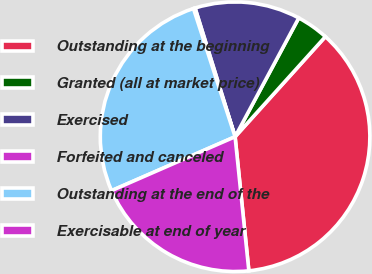<chart> <loc_0><loc_0><loc_500><loc_500><pie_chart><fcel>Outstanding at the beginning<fcel>Granted (all at market price)<fcel>Exercised<fcel>Forfeited and canceled<fcel>Outstanding at the end of the<fcel>Exercisable at end of year<nl><fcel>36.69%<fcel>3.85%<fcel>12.63%<fcel>0.2%<fcel>26.55%<fcel>20.08%<nl></chart> 